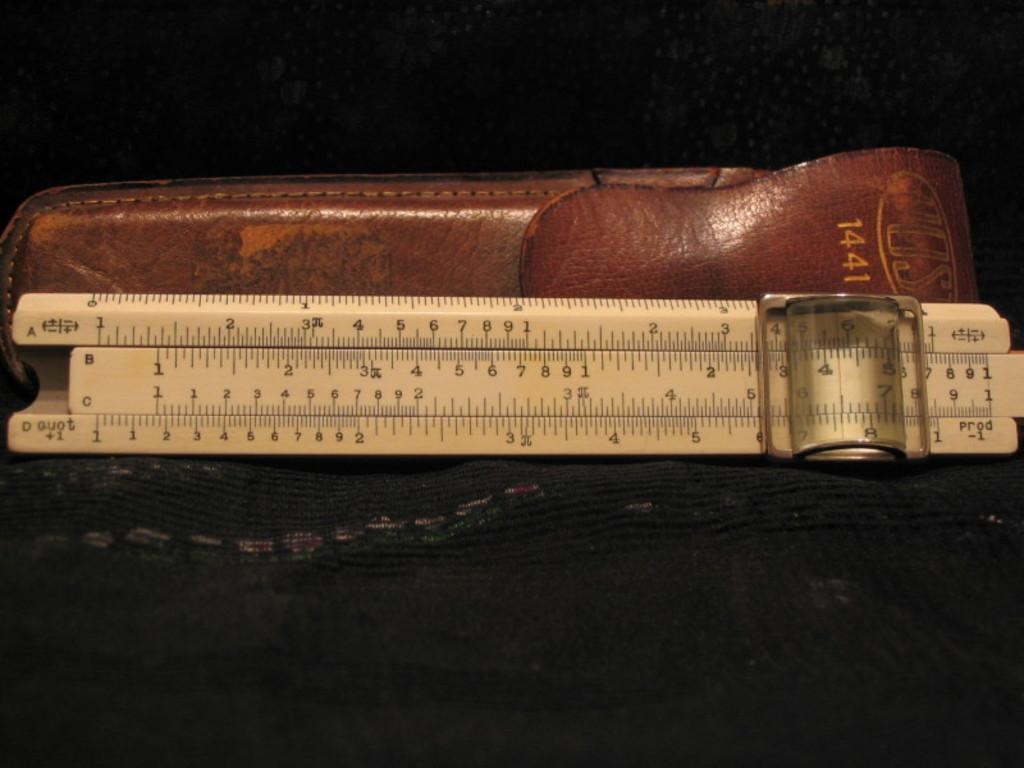<image>
Render a clear and concise summary of the photo. An old model 1441 Vost sliding scale ruler with leather pouch. 